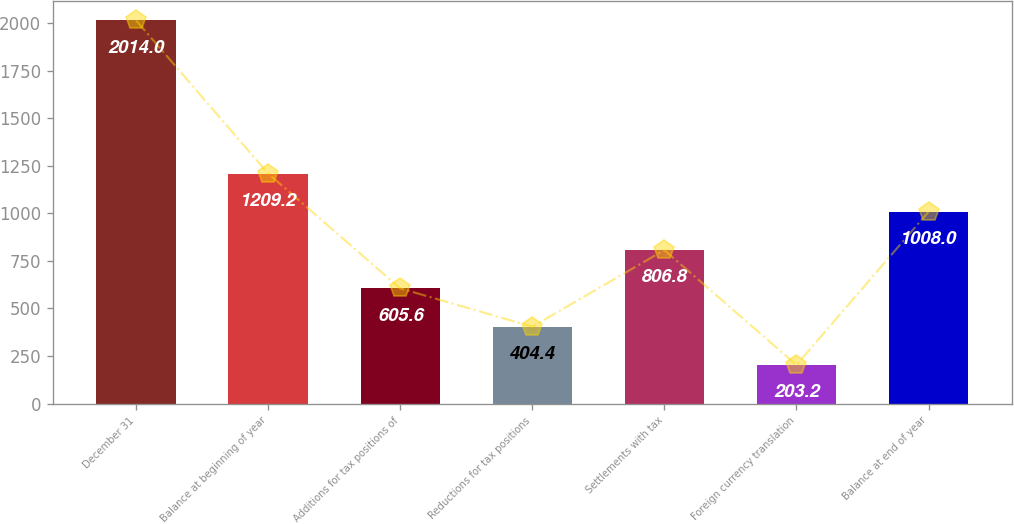Convert chart to OTSL. <chart><loc_0><loc_0><loc_500><loc_500><bar_chart><fcel>December 31<fcel>Balance at beginning of year<fcel>Additions for tax positions of<fcel>Reductions for tax positions<fcel>Settlements with tax<fcel>Foreign currency translation<fcel>Balance at end of year<nl><fcel>2014<fcel>1209.2<fcel>605.6<fcel>404.4<fcel>806.8<fcel>203.2<fcel>1008<nl></chart> 